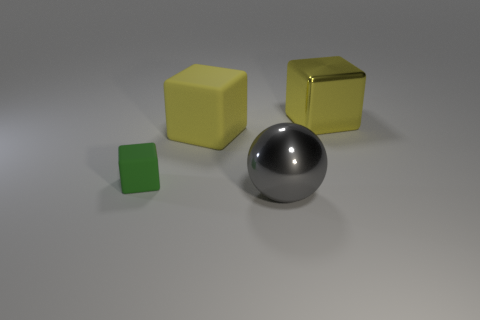Are there any yellow metal blocks in front of the yellow metallic thing? no 